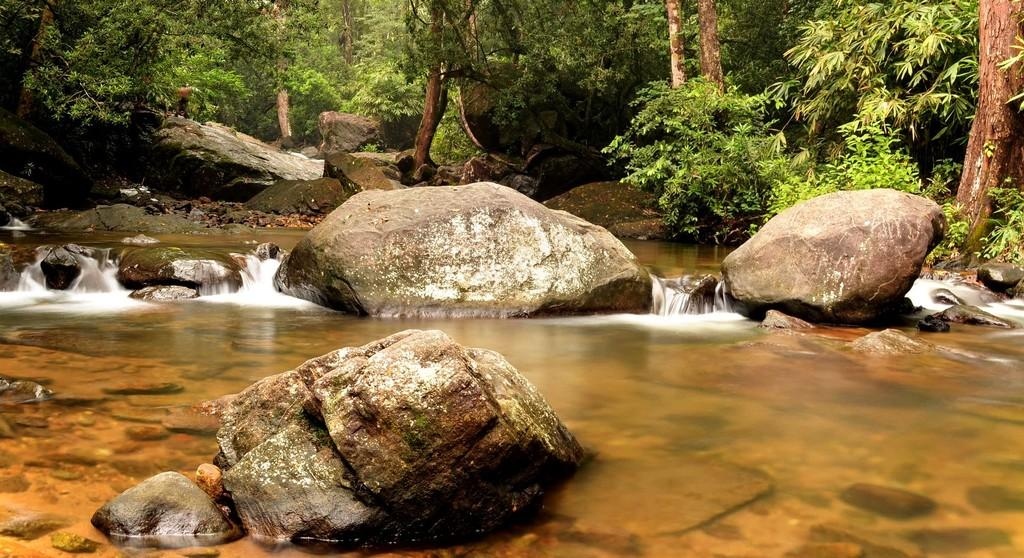What is located at the bottom of the image? There is a river at the bottom of the image. What can be seen in the river? There are stones in the water. What type of vegetation is visible in the background of the image? There are many trees in the background of the image. What else can be seen in the background of the image? There are rocks in the background of the image. Can you see a monkey climbing one of the trees in the image? There is no monkey present in the image; it only features a river, stones, trees, and rocks. How many chickens are visible in the image? There are no chickens present in the image. 